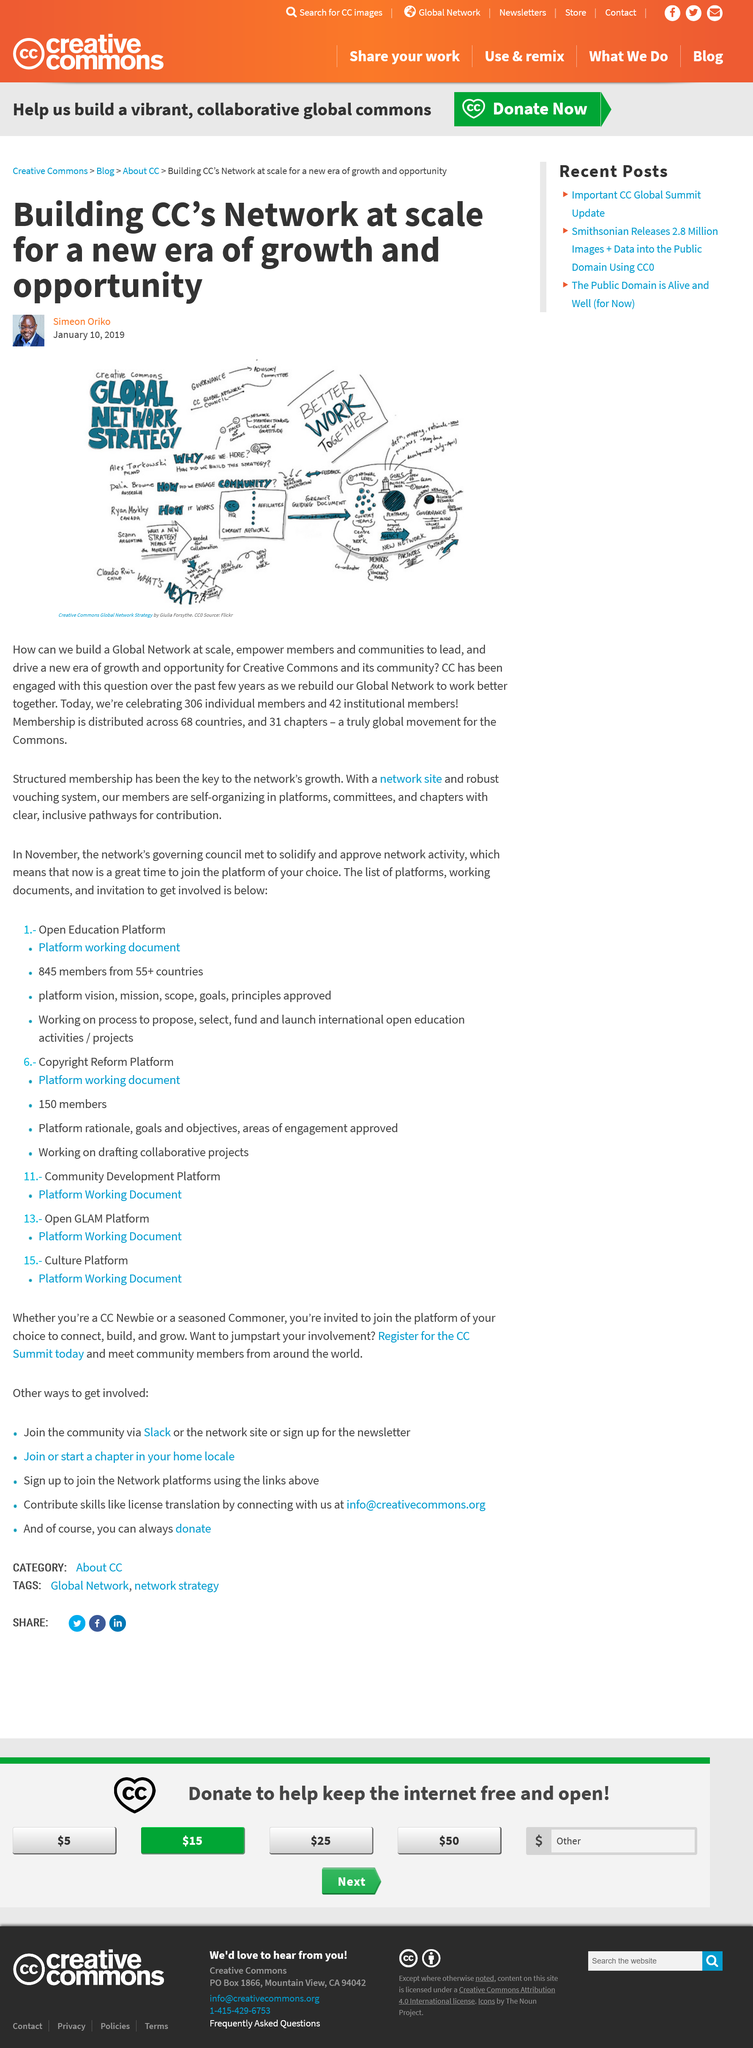Point out several critical features in this image. The article was written on January 10, 2019, and it was written on January 10, 2019. The Creative Commons network is an organization that stands for CC. It has 306 individual members. The author of this article is Simeon Oriko. 